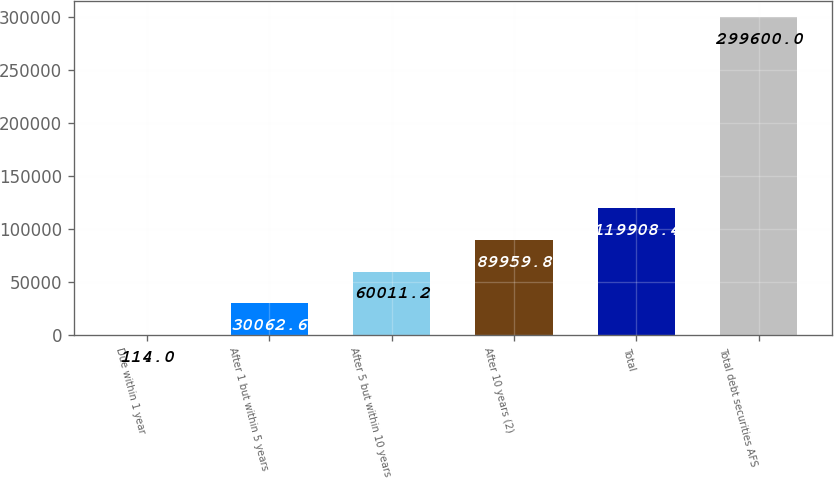<chart> <loc_0><loc_0><loc_500><loc_500><bar_chart><fcel>Due within 1 year<fcel>After 1 but within 5 years<fcel>After 5 but within 10 years<fcel>After 10 years (2)<fcel>Total<fcel>Total debt securities AFS<nl><fcel>114<fcel>30062.6<fcel>60011.2<fcel>89959.8<fcel>119908<fcel>299600<nl></chart> 